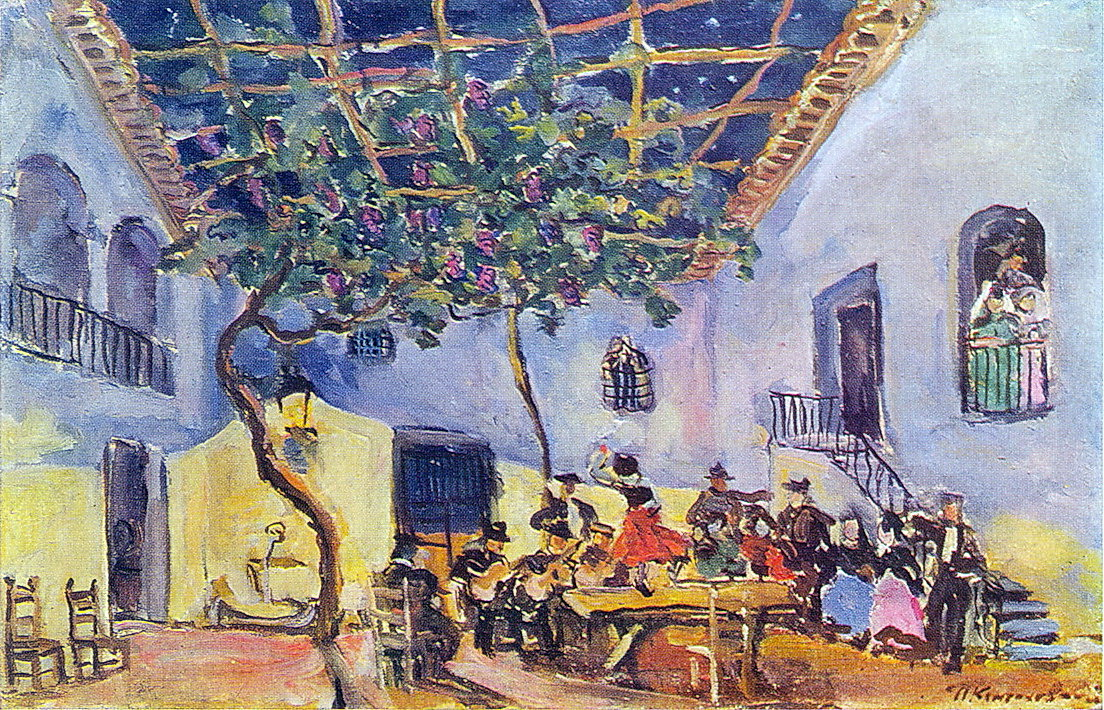If the scene were part of a dream, what might the dreamer be feeling or experiencing? If the scene were part of a dream, the dreamer might be experiencing feelings of joy, warmth, and a deep connection to others. The lush courtyard and the vibrant social gathering could symbolize the dreamer's longing for community and celebration. The rich colors and fluid brushstrokes could be interpreted as the dreamer's subconscious expressing a desire for freedom, creativity, and emotional expression. The dreamer might feel a sense of nostalgia, perhaps recalling fond memories of past gatherings, or a yearning for future moments of togetherness and happiness. Overall, the dream could evoke a sense of comfort, peace, and an appreciation for the beauty of life’s simple pleasures. 